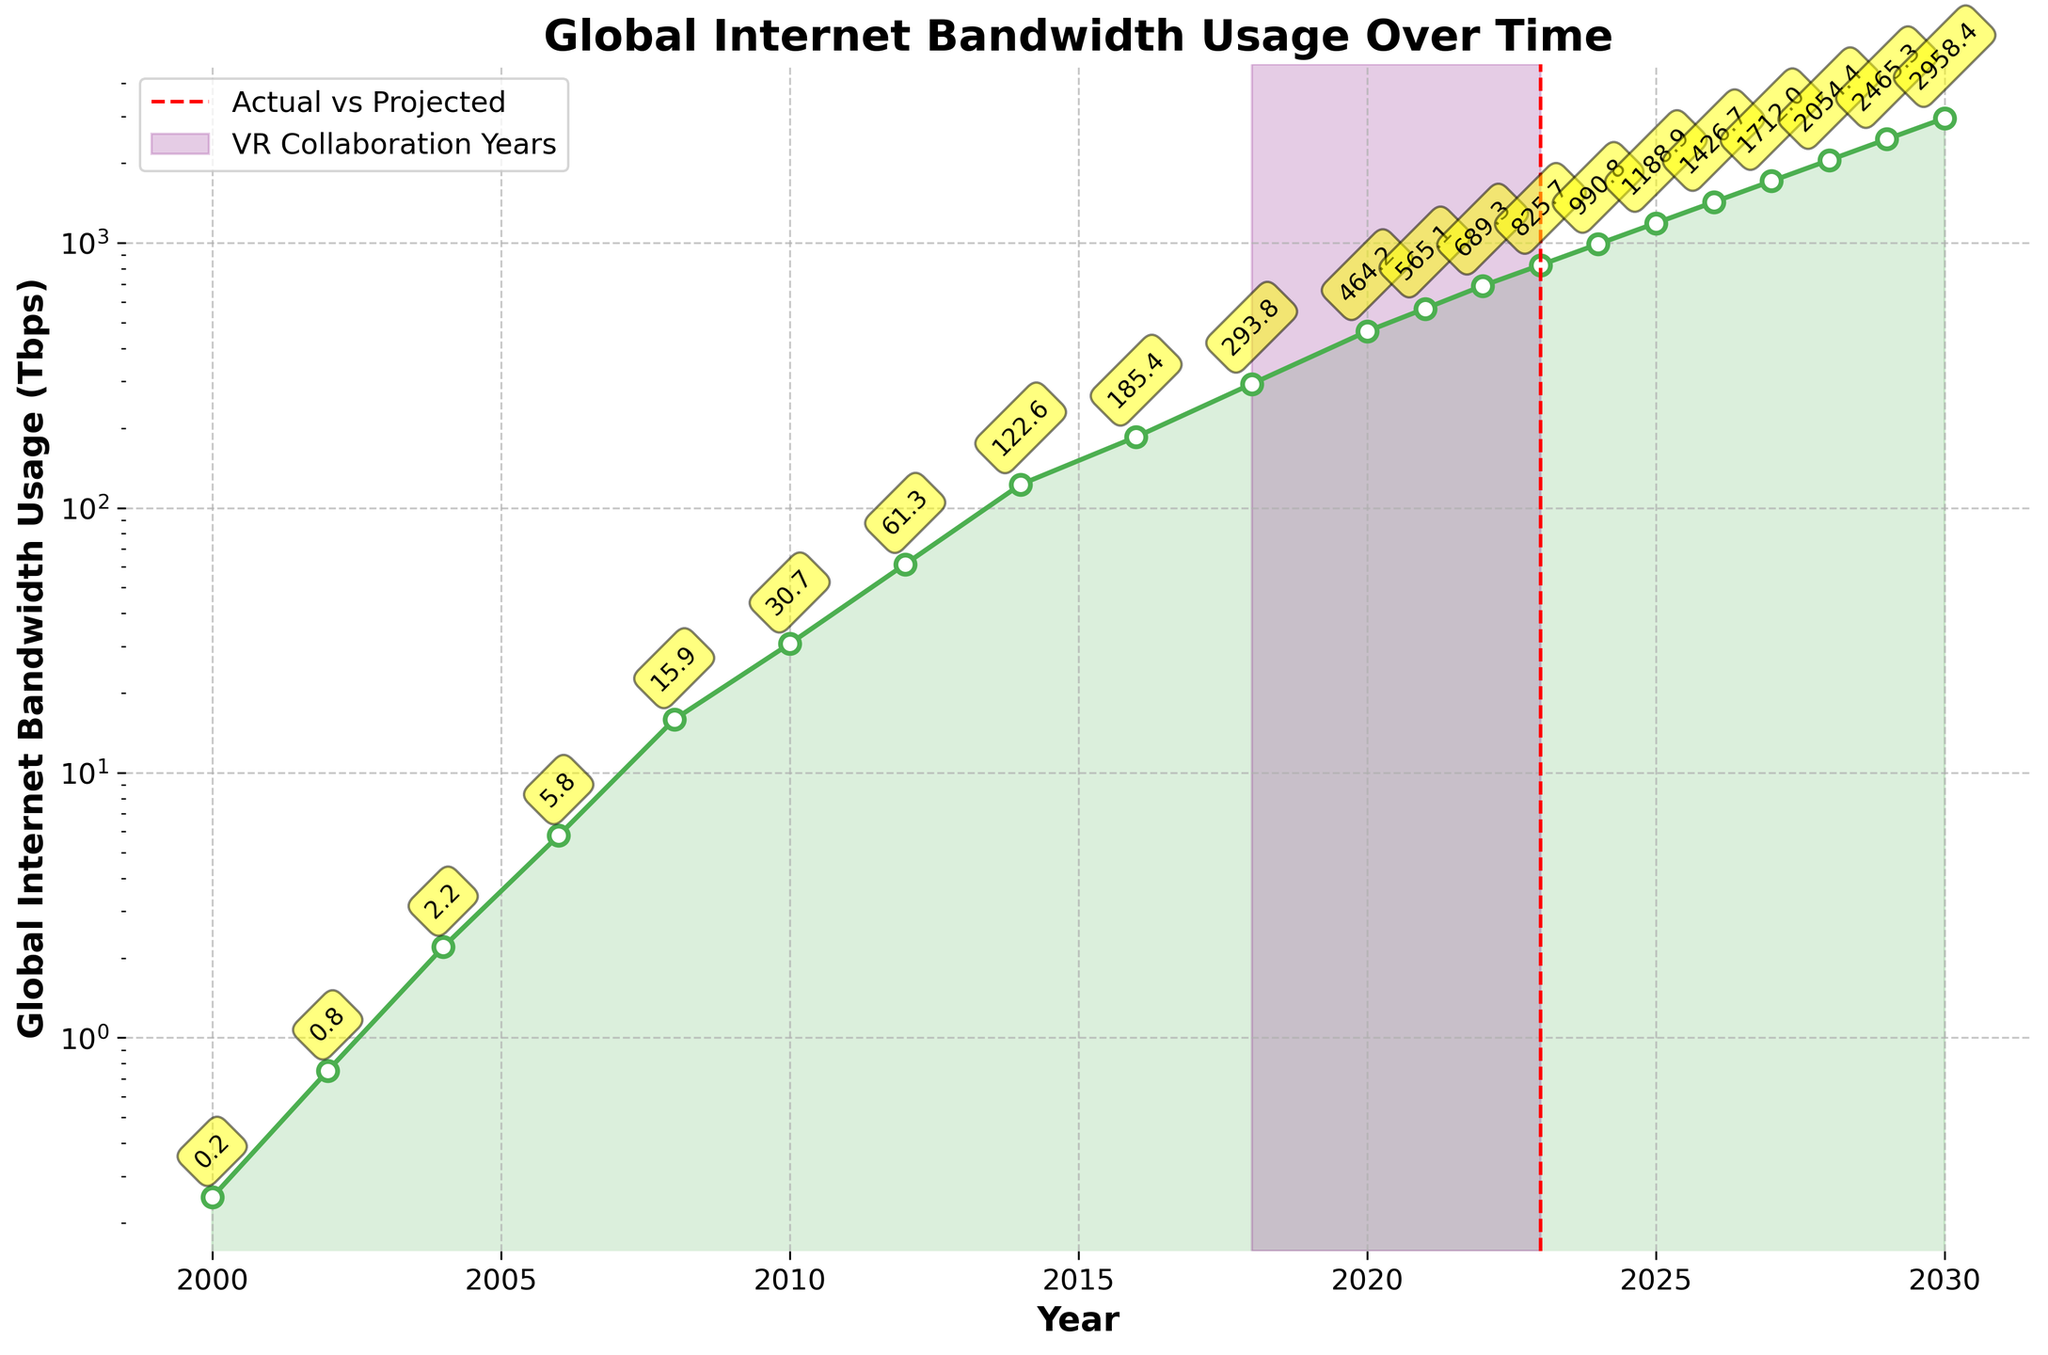What year represents the highest actual global internet bandwidth usage? To find the highest actual bandwidth usage, look for the last actual data point before projections start, which is marked by a red dashed line at 2023. The value for 2023 is 825.7 Tbps, which is the highest actual usage reported.
Answer: 2023 What is the projected global internet bandwidth usage for 2030? Projections start after the red dashed line at 2023. Locate the value for 2030 on the projection part of the plot. The chart shows the projected usage is 2958.4 Tbps for 2030.
Answer: 2958.4 Tbps During which years was the bandwidth usage under 1 Tbps? Identify the years on the x-axis and check which corresponding y-axis values are below 1 Tbps. Usage is under 1 Tbps for the years 2000 (0.25), 2002 (0.75).
Answer: 2000, 2002 How does global internet bandwidth usage in 2014 compare to 2024? Compare the values for 2014 and 2024 from the plot. For 2014, it's 122.6 Tbps, and for 2024, it's 990.8 Tbps. The bandwidth usage significantly increased from 122.6 Tbps in 2014 to 990.8 Tbps in 2024.
Answer: 990.8 Tbps - 122.6 Tbps = 868.2 Tbps increase What is the average global internet bandwidth usage from 2000 to 2006? Sum the data points from 2000 to 2006 (0.25, 0.75, 2.2, 5.8) and divide by the number of data points (4). (0.25 + 0.75 + 2.2 + 5.8) / 4 = 9 / 4 = 2.25 Tbps.
Answer: 2.25 Tbps Which period experienced the fastest growth in global internet bandwidth usage? Identify the period with the steepest curve on the plot. The period between 2023 (825.7 Tbps) and 2030 (2958.4 Tbps) shows a rapid growth, which indicates it is the fastest.
Answer: 2023-2030 In what way is the period from 2018 to 2023 visually distinguished on the chart? The period from 2018 to 2023 is highlighted by a purple shaded region on the chart, indicating the VR collaboration years.
Answer: Highlighted purple span What is the difference in global internet bandwidth usage between 2010 and 2020? Locate the values for 2010 (30.7 Tbps) and 2020 (464.2 Tbps). Calculate the difference: 464.2 - 30.7 = 433.5 Tbps.
Answer: 433.5 Tbps What pattern can you observe regarding the trend of global internet bandwidth usage over time? Observe the overall shape of the line. The bandwidth usage shows an exponential growth trend over the years, especially evident with the logarithmic y-axis.
Answer: Exponential growth 